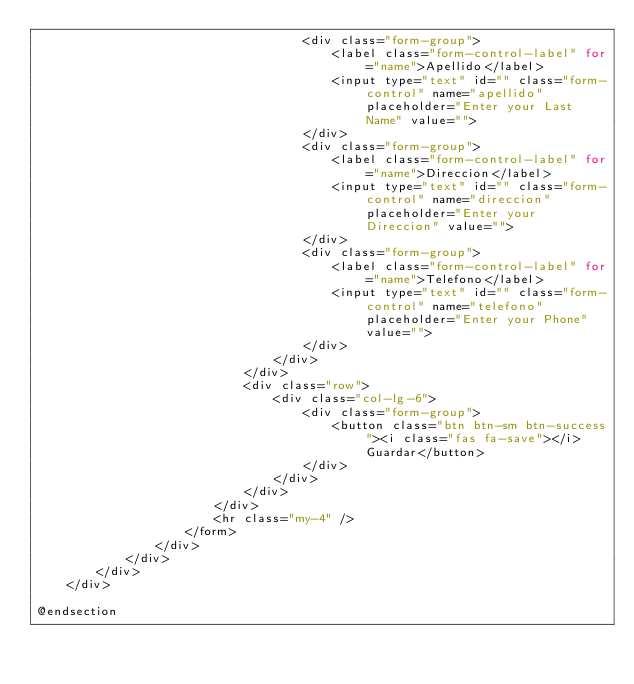<code> <loc_0><loc_0><loc_500><loc_500><_PHP_>                                    <div class="form-group">
                                        <label class="form-control-label" for="name">Apellido</label>
                                        <input type="text" id="" class="form-control" name="apellido" placeholder="Enter your Last Name" value="">
                                    </div>
                                    <div class="form-group">
                                        <label class="form-control-label" for="name">Direccion</label>
                                        <input type="text" id="" class="form-control" name="direccion" placeholder="Enter your Direccion" value="">
                                    </div>
                                    <div class="form-group">
                                        <label class="form-control-label" for="name">Telefono</label>
                                        <input type="text" id="" class="form-control" name="telefono" placeholder="Enter your Phone" value="">
                                    </div>
                                </div>
                            </div>
                            <div class="row">
                                <div class="col-lg-6">
                                    <div class="form-group">
                                        <button class="btn btn-sm btn-success"><i class="fas fa-save"></i> Guardar</button>
                                    </div>
                                </div>
                            </div>
                        </div>
                        <hr class="my-4" />
                    </form>
                </div>
            </div>
        </div>
    </div>

@endsection
</code> 